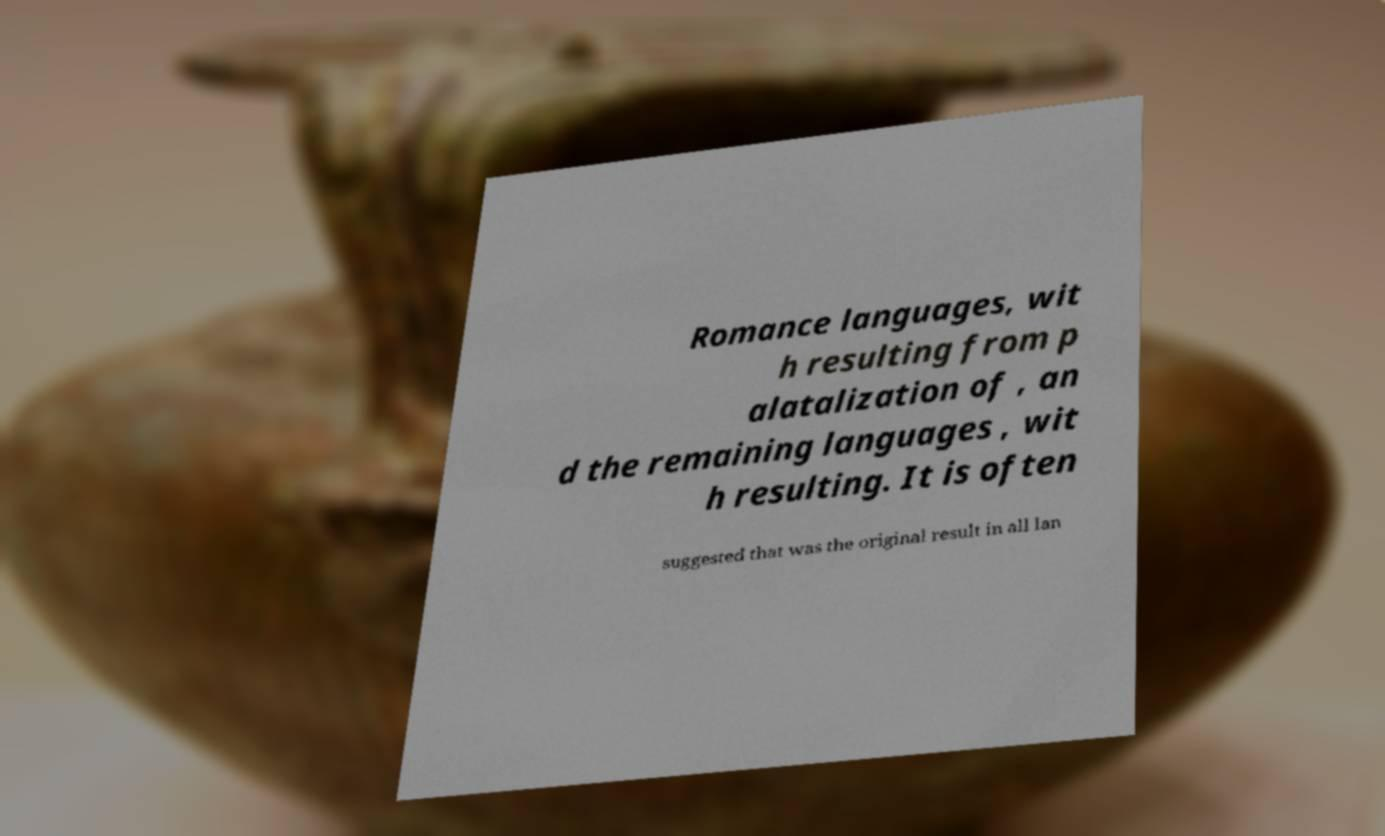Could you assist in decoding the text presented in this image and type it out clearly? Romance languages, wit h resulting from p alatalization of , an d the remaining languages , wit h resulting. It is often suggested that was the original result in all lan 